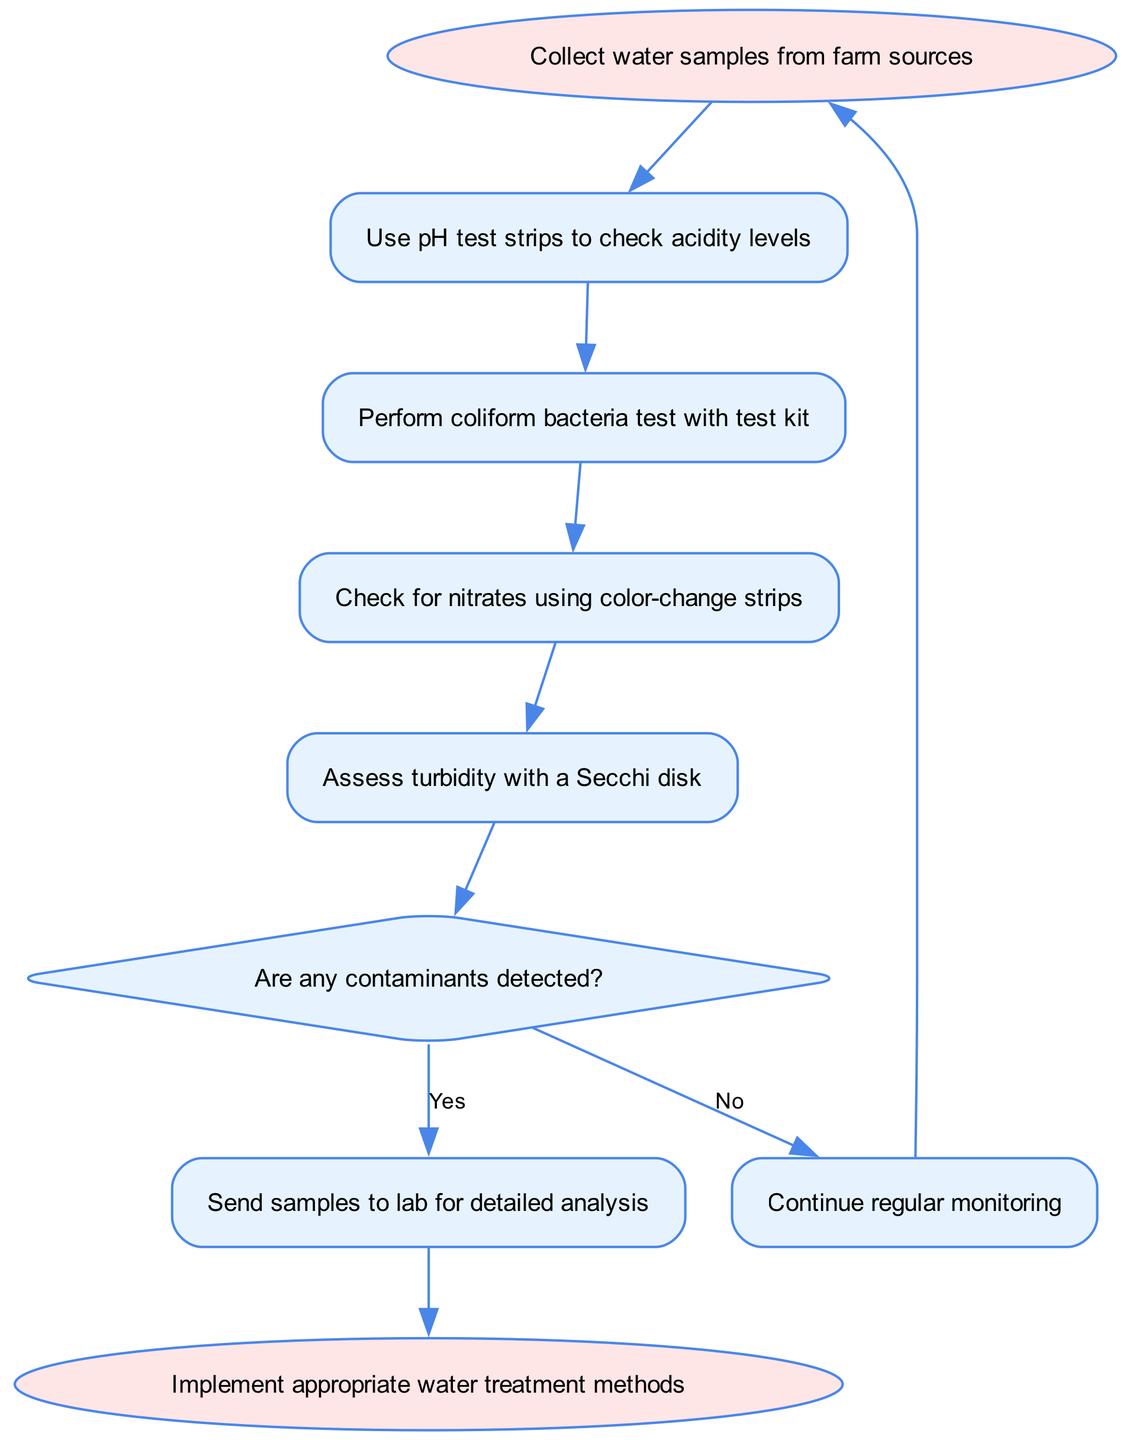What is the first step in the process? The first step in the process is to collect water samples from farm sources. This is directly stated in the starting node of the flowchart.
Answer: Collect water samples from farm sources How many steps are there before the decision point? To get to the decision point, you must go through four steps: use pH test strips, perform coliform bacteria test, check for nitrates, and assess turbidity. Counting these gives a total of four steps before the decision.
Answer: Four What happens if no contaminants are detected? If no contaminants are detected, according to the flowchart, the next action is to continue regular monitoring. This action is outlined in the 'no' path from the decision node.
Answer: Continue regular monitoring What follows after detecting contaminants? Detecting contaminants leads to sending the water samples to a lab for detailed analysis. This is specified in the 'yes' path from the decision node.
Answer: Send samples to lab for detailed analysis How many nodes represent steps in the process? There are four nodes that represent the steps in the process (steps 1 through 4), which exclude the starting, decision, and ending nodes. This is calculated by identifying the respective nodes listed in the elements section.
Answer: Four What action is taken at the end of the process? At the end of the process, the action taken is to implement appropriate water treatment methods. This is stated in the end node of the flowchart.
Answer: Implement appropriate water treatment methods Which step includes checking for nitrates? The step that includes checking for nitrates is the third step in the sequence, which specifically mentions checking for nitrates using color-change strips.
Answer: Check for nitrates using color-change strips What is the decision point evaluating? The decision point evaluates whether any contaminants have been detected in the water samples collected. This is represented by the diamond-shaped decision node in the diagram.
Answer: Any contaminants detected What is the relationship between steps 3 and 4? The relationship between steps 3 and 4 is sequential; after checking for nitrates in step 3, you proceed to assess turbidity with a Secchi disk in step 4. This is outlined by the directed edge connecting these two nodes.
Answer: Sequential relationship 